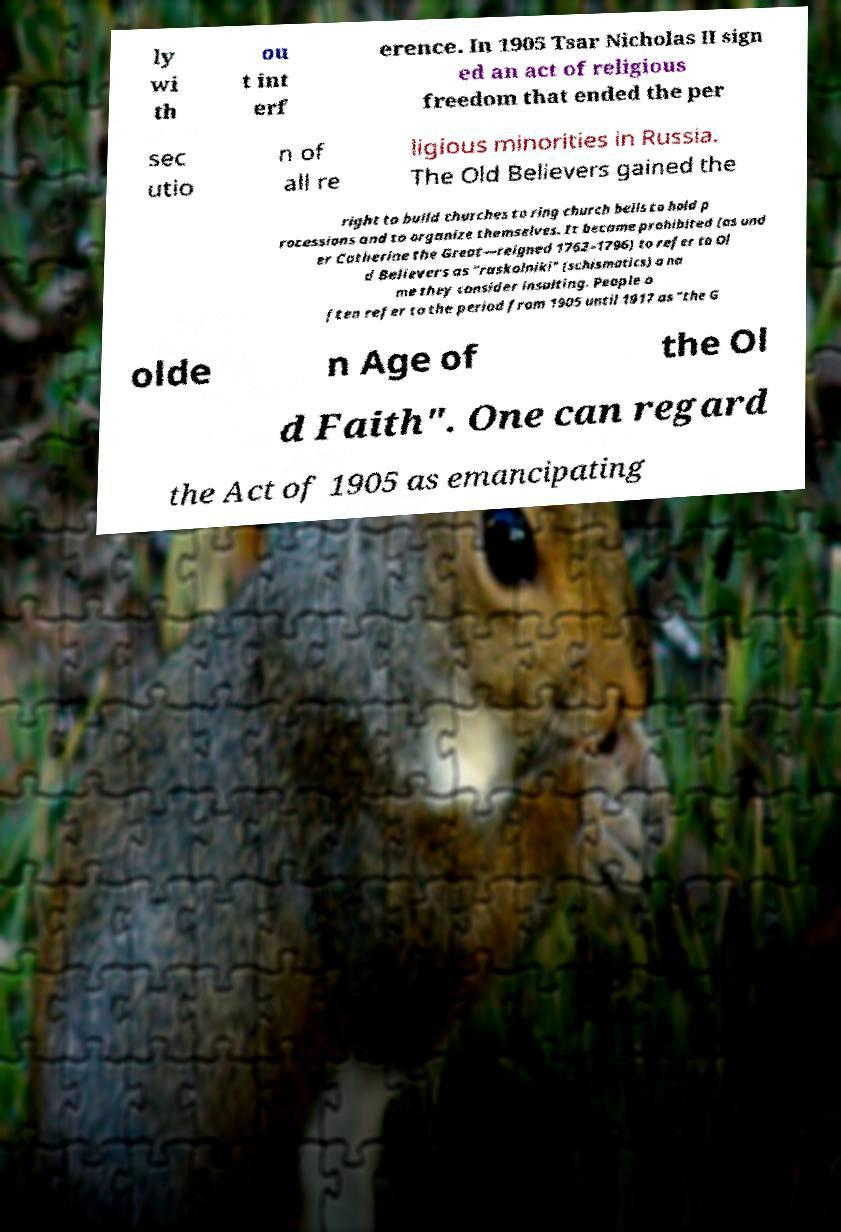Please read and relay the text visible in this image. What does it say? ly wi th ou t int erf erence. In 1905 Tsar Nicholas II sign ed an act of religious freedom that ended the per sec utio n of all re ligious minorities in Russia. The Old Believers gained the right to build churches to ring church bells to hold p rocessions and to organize themselves. It became prohibited (as und er Catherine the Great—reigned 1762–1796) to refer to Ol d Believers as "raskolniki" (schismatics) a na me they consider insulting. People o ften refer to the period from 1905 until 1917 as "the G olde n Age of the Ol d Faith". One can regard the Act of 1905 as emancipating 